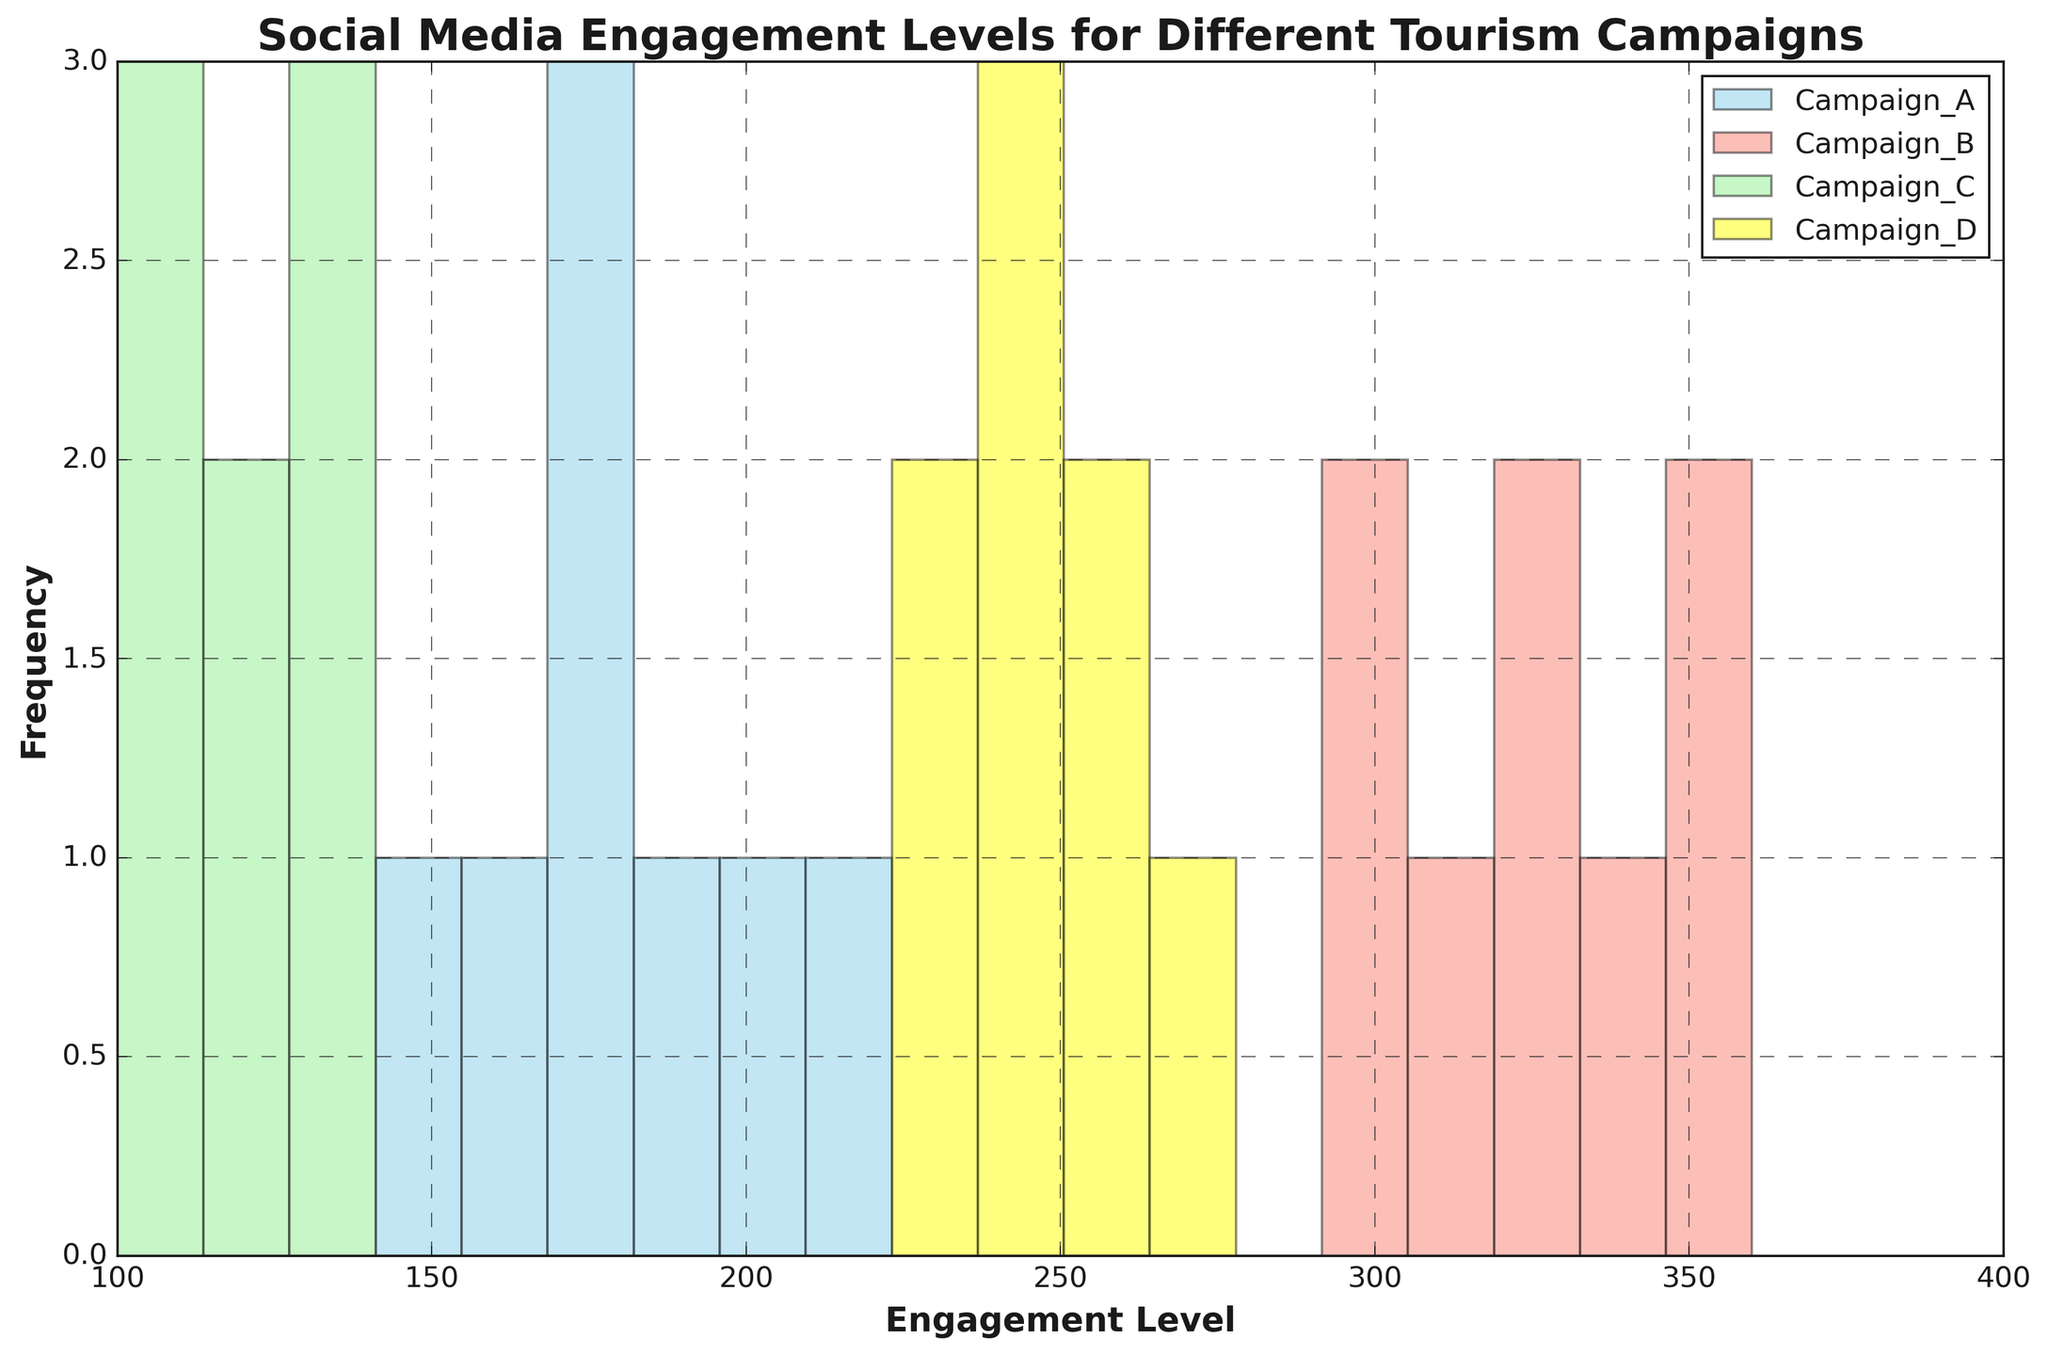What campaign shows the highest engagement levels overall? By looking at the histogram bars for each campaign, we can compare the highest points reached by each group. Campaign B's histogram shows the highest engagement levels, with frequencies around 300-360.
Answer: Campaign B Which campaign has the most engagement levels below 200? Campaign C and Campaign A have engagement levels below 200, but Campaign C shows more frequencies concentrated below 200 in comparison to Campaign A.
Answer: Campaign C What is the average highest engagement level for Campaigns A and B? To compute this, identify the peak engagement levels from both campaigns (Campaign A: 210, Campaign B: 360), and find the average: (210 + 360) / 2 = 285.
Answer: 285 Which campaign's engagement levels have the smallest range? Calculate the range for each campaign by subtracting the minimum engagement level from the maximum engagement level. Campaign D has the smallest range (265 - 230 = 35).
Answer: Campaign D Are there any campaigns with overlapping engagement levels? By inspecting the x-axis (Engagement Levels) range and histogram bins, Campaigns A and C have overlapping engagement levels in the 100-200 range, while Campaigns B and D have overlapping engagement levels in the 230-360 range.
Answer: Yes Which campaign has the highest frequency of engagement levels in the 100-150 range? Check the histograms to see where the tallest bars in the 100-150 range occur. Campaign C has the highest frequency in this range.
Answer: Campaign C Compare the average engagement levels of Campaign A and Campaign D. Which one is higher? Calculate the average for Campaign A [(150 + 180 + 200 + 170 + 190 + 160 + 210 + 175)/8 = 179.38] and Campaign D [(240 + 260 + 250 + 245 + 255 + 235 + 265 + 230)/8 = 247.5], then compare the two.
Answer: Campaign D What's the frequency of Campaign B's engagement levels in the 340-360 range? Identify the bars for Campaign B between 340-360 and add their frequencies (340-350: 1, 350-360: 1).
Answer: 2 